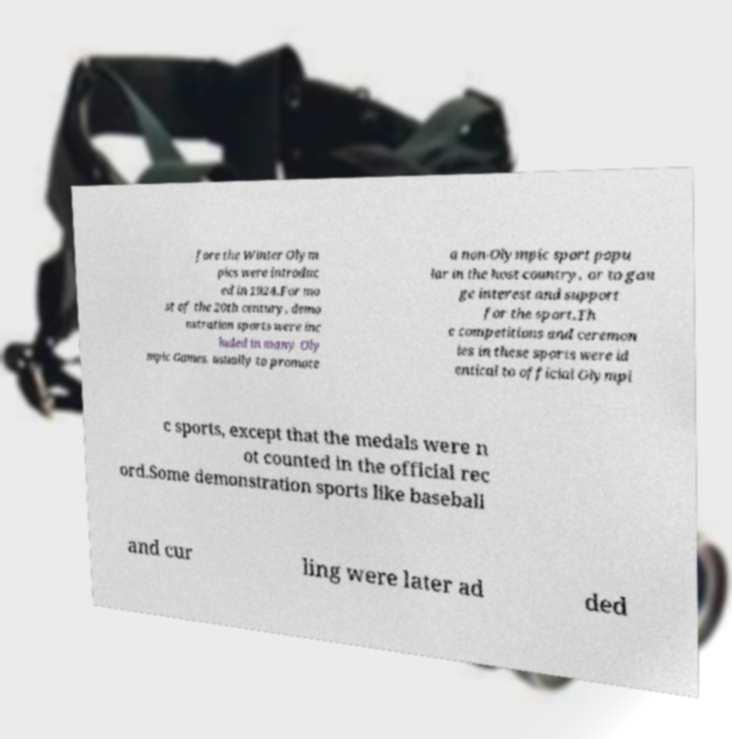Could you extract and type out the text from this image? fore the Winter Olym pics were introduc ed in 1924.For mo st of the 20th century, demo nstration sports were inc luded in many Oly mpic Games, usually to promote a non-Olympic sport popu lar in the host country, or to gau ge interest and support for the sport.Th e competitions and ceremon ies in these sports were id entical to official Olympi c sports, except that the medals were n ot counted in the official rec ord.Some demonstration sports like baseball and cur ling were later ad ded 